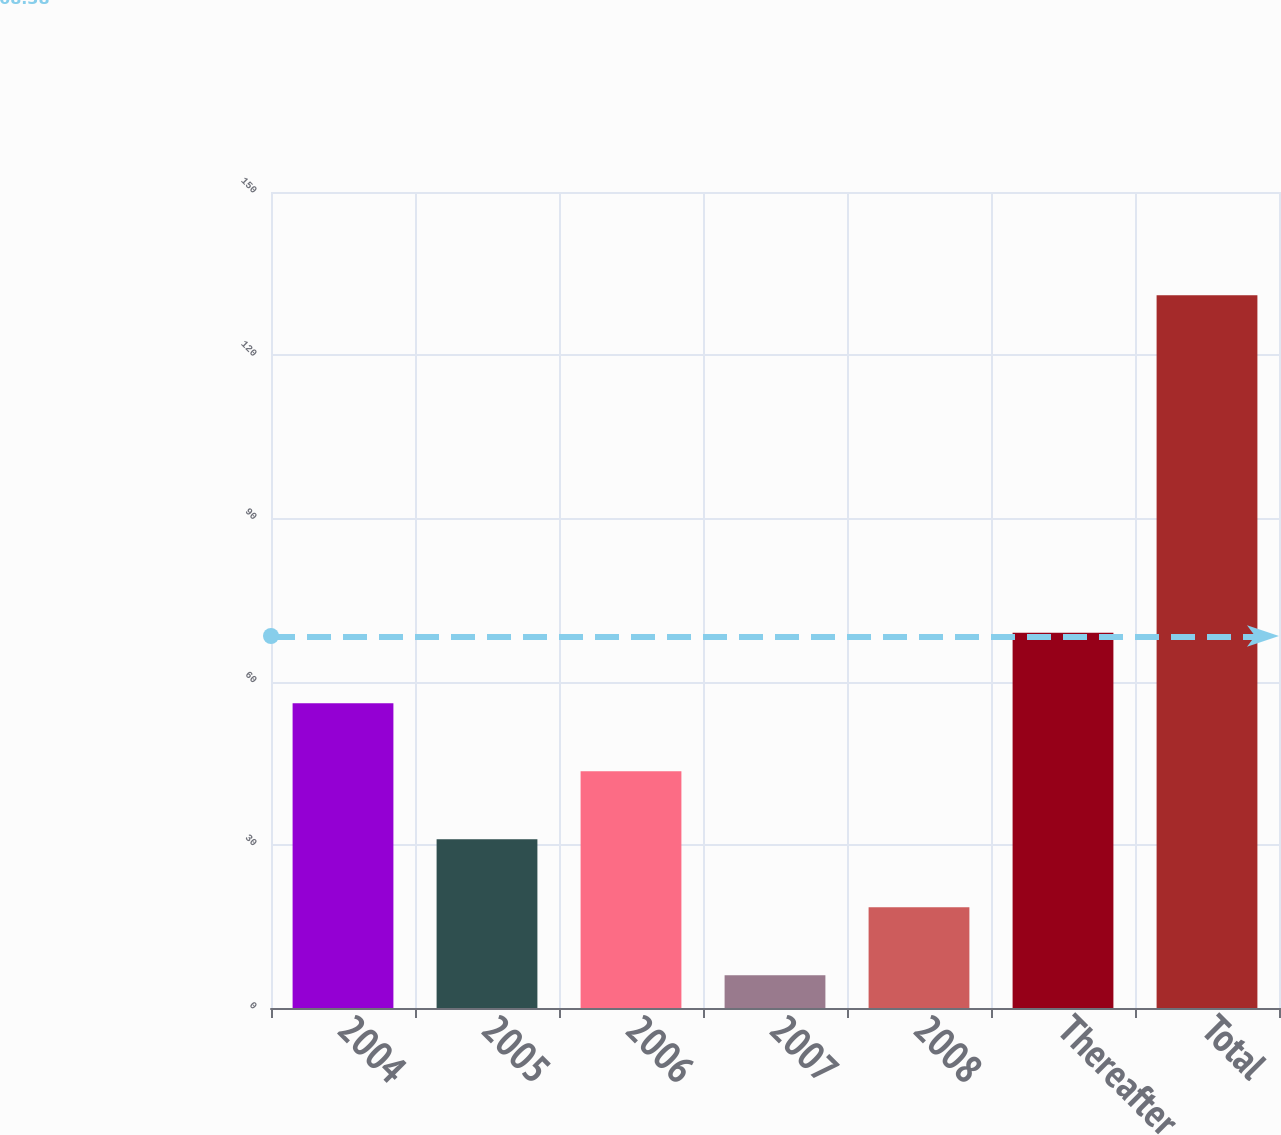Convert chart. <chart><loc_0><loc_0><loc_500><loc_500><bar_chart><fcel>2004<fcel>2005<fcel>2006<fcel>2007<fcel>2008<fcel>Thereafter<fcel>Total<nl><fcel>56<fcel>31<fcel>43.5<fcel>6<fcel>18.5<fcel>69<fcel>131<nl></chart> 